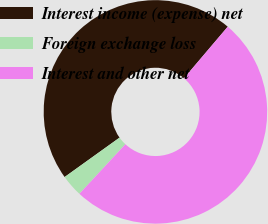Convert chart to OTSL. <chart><loc_0><loc_0><loc_500><loc_500><pie_chart><fcel>Interest income (expense) net<fcel>Foreign exchange loss<fcel>Interest and other net<nl><fcel>46.11%<fcel>3.19%<fcel>50.71%<nl></chart> 